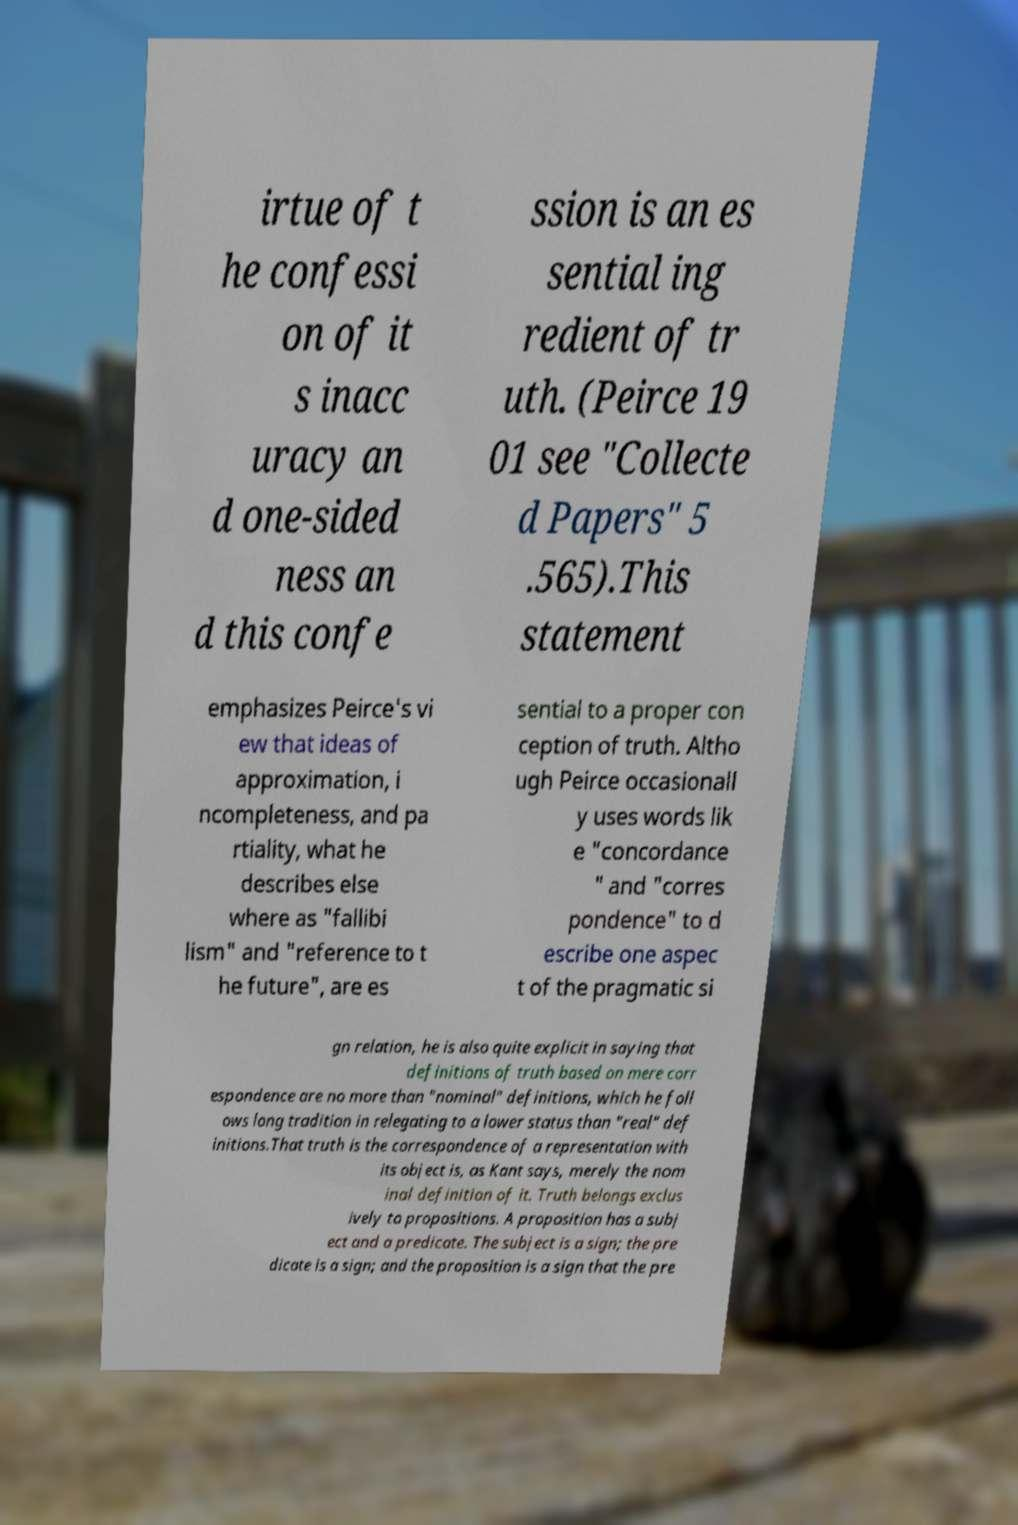For documentation purposes, I need the text within this image transcribed. Could you provide that? irtue of t he confessi on of it s inacc uracy an d one-sided ness an d this confe ssion is an es sential ing redient of tr uth. (Peirce 19 01 see "Collecte d Papers" 5 .565).This statement emphasizes Peirce's vi ew that ideas of approximation, i ncompleteness, and pa rtiality, what he describes else where as "fallibi lism" and "reference to t he future", are es sential to a proper con ception of truth. Altho ugh Peirce occasionall y uses words lik e "concordance " and "corres pondence" to d escribe one aspec t of the pragmatic si gn relation, he is also quite explicit in saying that definitions of truth based on mere corr espondence are no more than "nominal" definitions, which he foll ows long tradition in relegating to a lower status than "real" def initions.That truth is the correspondence of a representation with its object is, as Kant says, merely the nom inal definition of it. Truth belongs exclus ively to propositions. A proposition has a subj ect and a predicate. The subject is a sign; the pre dicate is a sign; and the proposition is a sign that the pre 